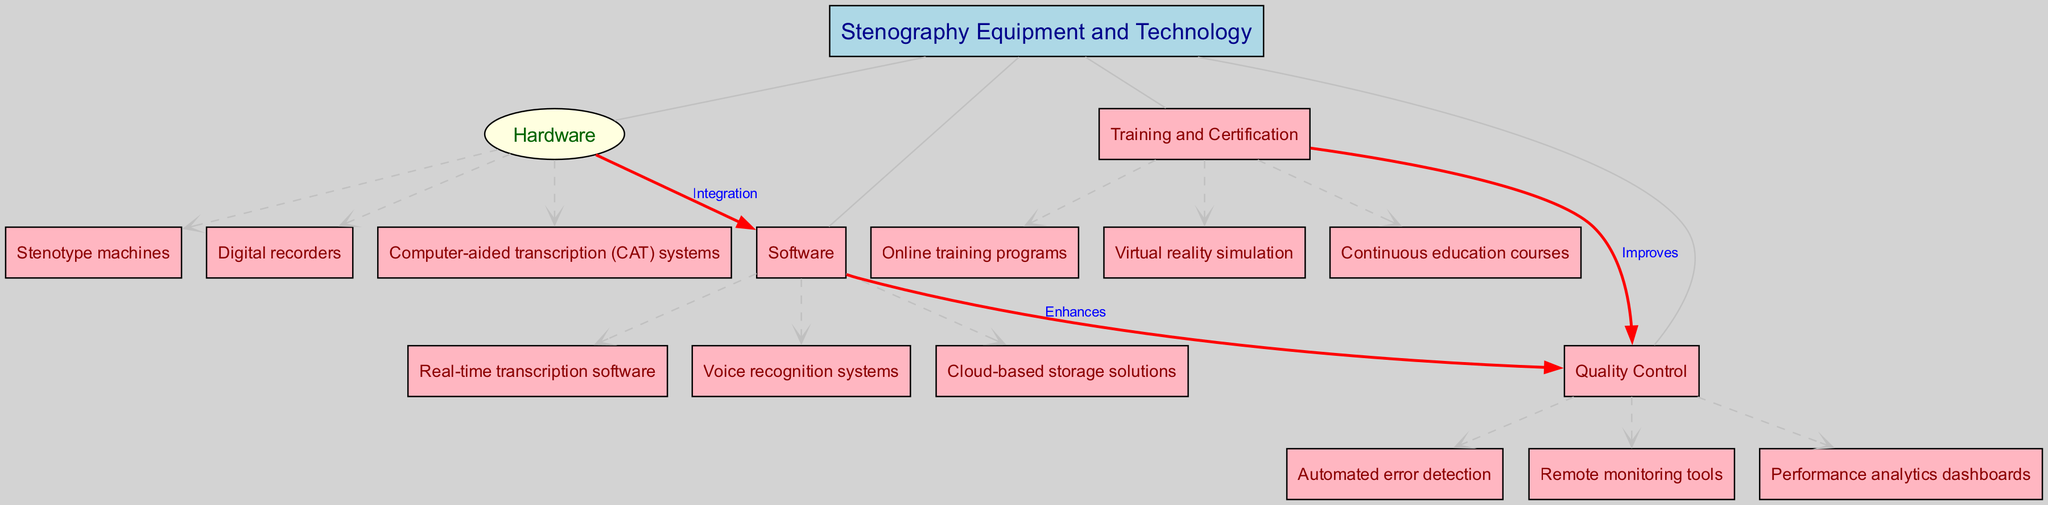What is the center node of the diagram? The center node is labeled "Stenography Equipment and Technology". This label is found at the middle of the diagram, indicating the main subject of the concept map.
Answer: Stenography Equipment and Technology How many main branches are there in the diagram? There are four main branches connected to the center node. These are "Hardware," "Software," "Training and Certification," and "Quality Control." The count can be observed by looking at the edges that connect these nodes to the center.
Answer: 4 What connects Hardware and Software? There is a labeled edge with the term "Integration" that connects the "Hardware" branch to the "Software" branch. This indicates a relationship indicating how these two components work together.
Answer: Integration Which sub-branch is under Software? One of the sub-branches under "Software" is "Real-time transcription software." This can be determined by looking at the sub-branches listed beneath the "Software" node.
Answer: Real-time transcription software How does Software enhance Quality Control? The "Software" node is connected to the "Quality Control" node with a labeled edge that states "Enhances." This indicates that advancements in software contribute positively to the quality control aspect.
Answer: Enhances What does Training and Certification improve? The label "Improves" connects "Training and Certification" to "Quality Control," showing that enhanced training and certification processes lead to better quality control in stenography practices.
Answer: Quality Control How many sub-branches are there under Hardware? There are three sub-branches under "Hardware" which include "Stenotype machines," "Digital recorders," and "Computer-aided transcription (CAT) systems." This can be verified by counting the nodes directly linked to the "Hardware" branch.
Answer: 3 What type of technology is mentioned under Quality Control? One type of technology mentioned under "Quality Control" is "Automated error detection." This can be identified by examining the sub-branches listed under the "Quality Control" node.
Answer: Automated error detection 